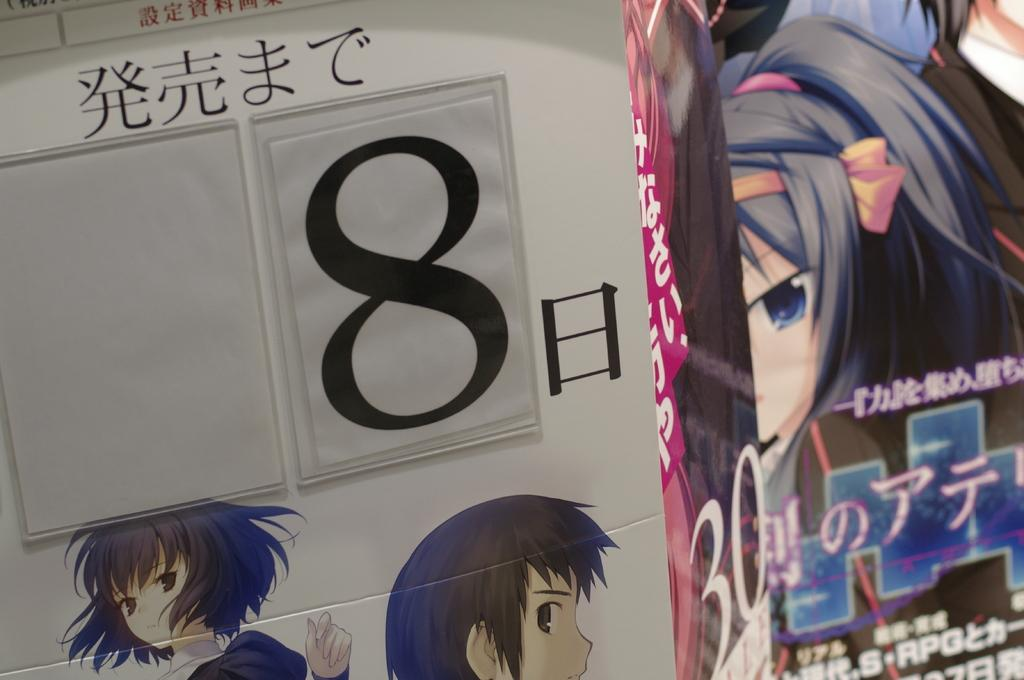What type of images are present in the image? There are cartoon images in the image. Can you describe the text on the wall in the image? Unfortunately, the specific text on the wall cannot be determined from the provided facts. What is the overall theme or subject of the image? Based on the presence of cartoon images, the image may have a playful or lighthearted theme. What type of whip is being used by the cartoon character in the image? There is no whip present in the image, as it only contains cartoon images and text on the wall. 